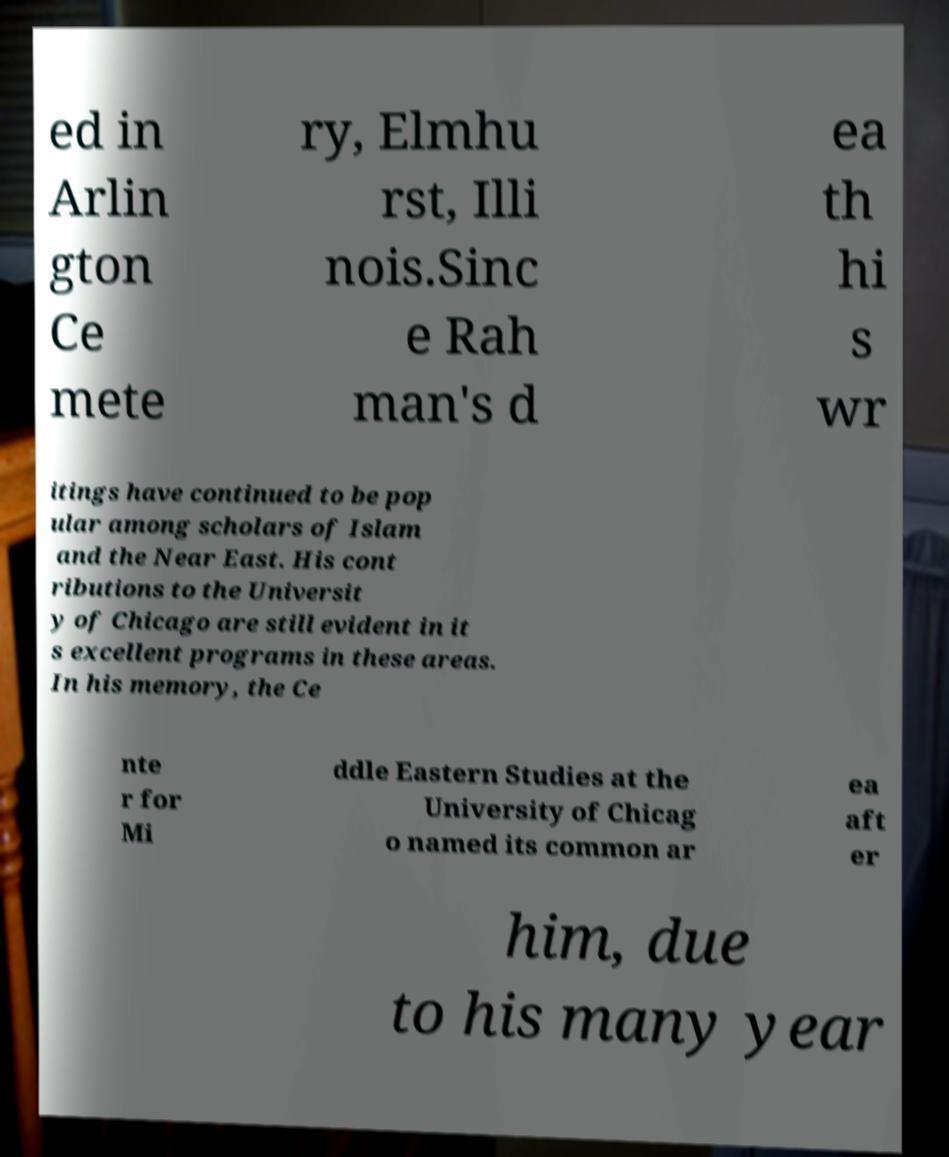Could you extract and type out the text from this image? ed in Arlin gton Ce mete ry, Elmhu rst, Illi nois.Sinc e Rah man's d ea th hi s wr itings have continued to be pop ular among scholars of Islam and the Near East. His cont ributions to the Universit y of Chicago are still evident in it s excellent programs in these areas. In his memory, the Ce nte r for Mi ddle Eastern Studies at the University of Chicag o named its common ar ea aft er him, due to his many year 